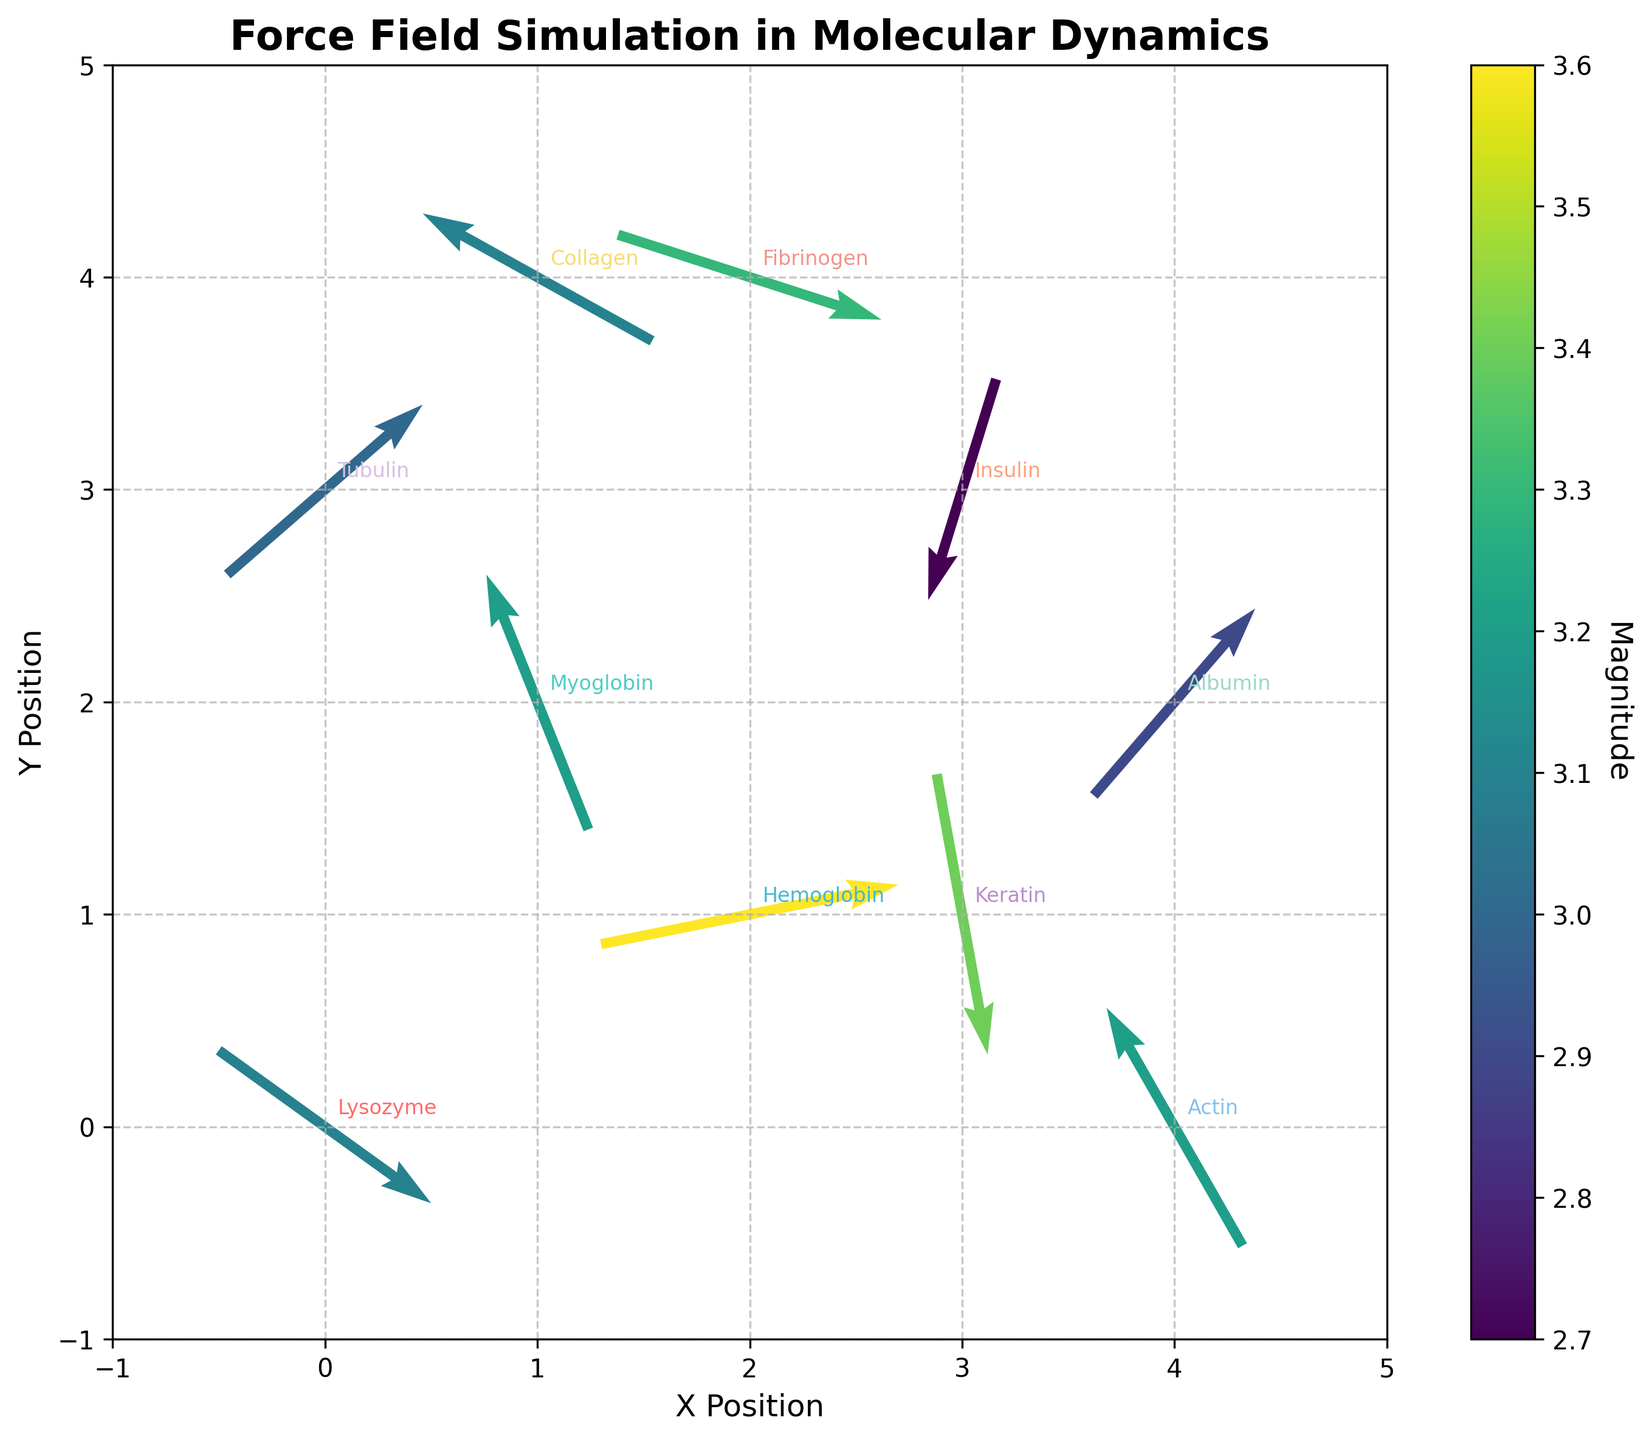What is the title of the plot? The title is located at the top of the figure. It reads, "Force Field Simulation in Molecular Dynamics."
Answer: Force Field Simulation in Molecular Dynamics How many protein labels are present in the plot? Each label corresponds to a protein in the plot. By counting them, there are ten protein labels visible.
Answer: 10 What are the x and y positions of Collagen? Locate the label "Collagen" in the plot. Collagen is positioned at x = 1 and y = 4.
Answer: x=1 and y=4 Which protein has the highest magnitude in the force field? The magnitude is encoded by the color intensity in the plot. Hemoglobin has the highest magnitude of 3.6, as indicated by the color bar.
Answer: Hemoglobin Between Actin and Keratin, which has a higher magnitude? The magnitudes for Actin and Keratin are 3.2 and 3.4 respectively. Comparing these values reveals that Keratin has a higher magnitude.
Answer: Keratin What are the u and v vector components for Myoglobin? By locating Myoglobin on the plot, its vector is observed with u = -1.2 and v = 3.0.
Answer: u=-1.2 and v=3.0 Does Insulin have a positive or negative v component? By analyzing the vector direction, Insulin's vector points downward, indicating a negative v component of -2.6.
Answer: Negative What is the average magnitude of the proteins located at y=2? Proteins at y=2 are Myoglobin, Albumin, and Actin with magnitudes 3.2, 2.9, and 3.2 respectively. The average is (3.2 + 2.9 + 3.2) / 3 = 3.1.
Answer: 3.1 What is the overall direction of the force field vectors for Keratin and Tubulin? Keratin's vector points mostly downwards and slightly to the right, while Tubulin's vector points diagonally upward to the right.
Answer: Keratin: downward-right, Tubulin: upward-right 